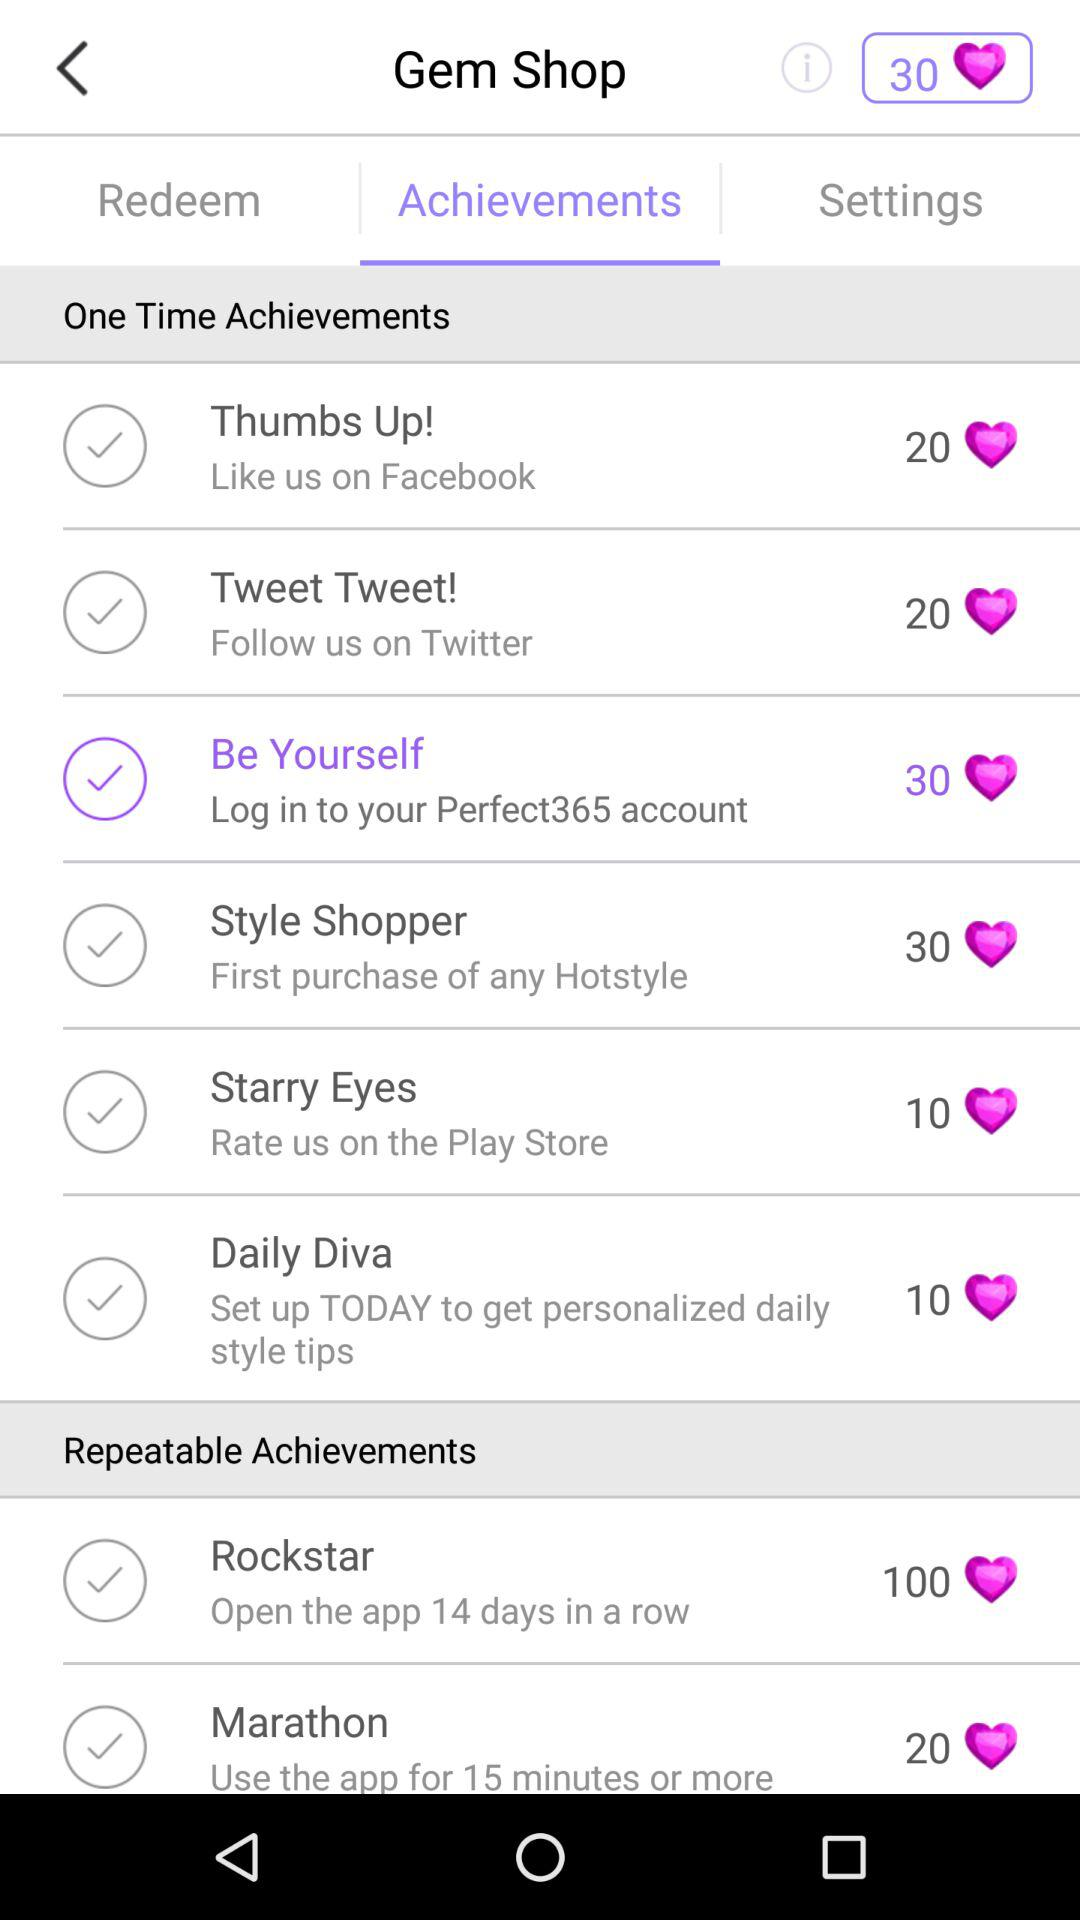How many achievements are repeatable?
Answer the question using a single word or phrase. 2 